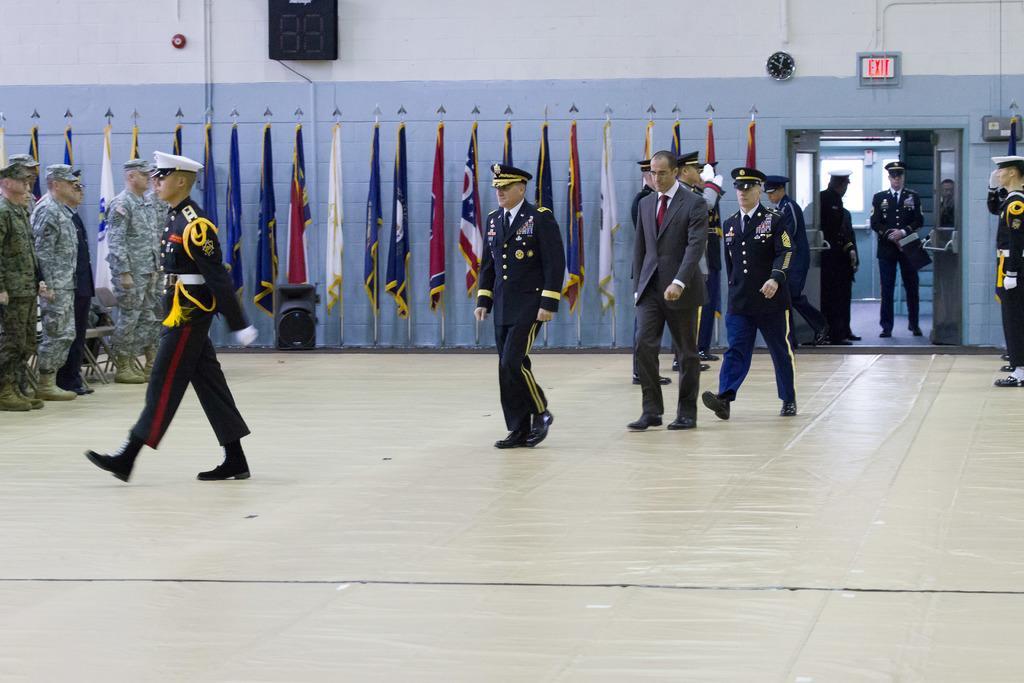Could you give a brief overview of what you see in this image? In the image there are many people with uniforms and caps on their heads. There are few people walking. Behind them there are speakers, flag poles and a clock and an exit board on the wall. And also there are doors. Behind the doors there are few people standing. 